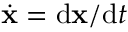Convert formula to latex. <formula><loc_0><loc_0><loc_500><loc_500>\dot { x } = d x / d t</formula> 